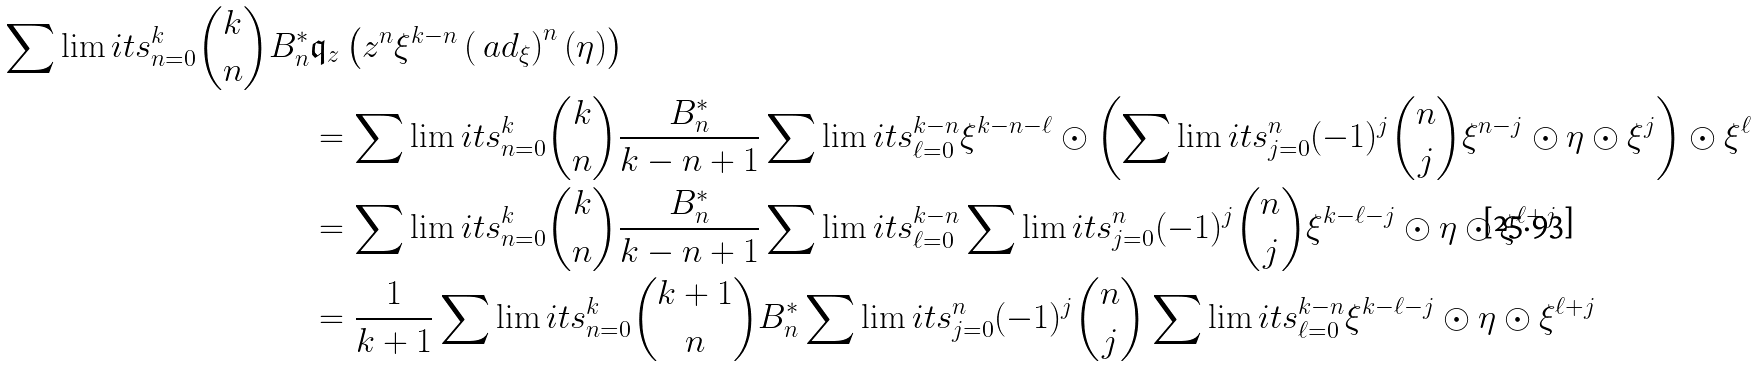Convert formula to latex. <formula><loc_0><loc_0><loc_500><loc_500>\sum \lim i t s _ { n = 0 } ^ { k } \binom { k } { n } B _ { n } ^ { * } & \mathfrak { q } _ { z } \left ( z ^ { n } \xi ^ { k - n } \left ( \ a d _ { \xi } \right ) ^ { n } ( \eta ) \right ) \\ & = \sum \lim i t s _ { n = 0 } ^ { k } \binom { k } { n } \frac { B _ { n } ^ { * } } { k - n + 1 } \sum \lim i t s _ { \ell = 0 } ^ { k - n } \xi ^ { k - n - \ell } \odot \left ( \sum \lim i t s _ { j = 0 } ^ { n } ( - 1 ) ^ { j } \binom { n } { j } \xi ^ { n - j } \odot \eta \odot \xi ^ { j } \right ) \odot \xi ^ { \ell } \\ & = \sum \lim i t s _ { n = 0 } ^ { k } \binom { k } { n } \frac { B _ { n } ^ { * } } { k - n + 1 } \sum \lim i t s _ { \ell = 0 } ^ { k - n } \sum \lim i t s _ { j = 0 } ^ { n } ( - 1 ) ^ { j } \binom { n } { j } \xi ^ { k - \ell - j } \odot \eta \odot \xi ^ { \ell + j } \\ & = \frac { 1 } { k + 1 } \sum \lim i t s _ { n = 0 } ^ { k } \binom { k + 1 } { n } B _ { n } ^ { * } \sum \lim i t s _ { j = 0 } ^ { n } ( - 1 ) ^ { j } \binom { n } { j } \sum \lim i t s _ { \ell = 0 } ^ { k - n } \xi ^ { k - \ell - j } \odot \eta \odot \xi ^ { \ell + j }</formula> 